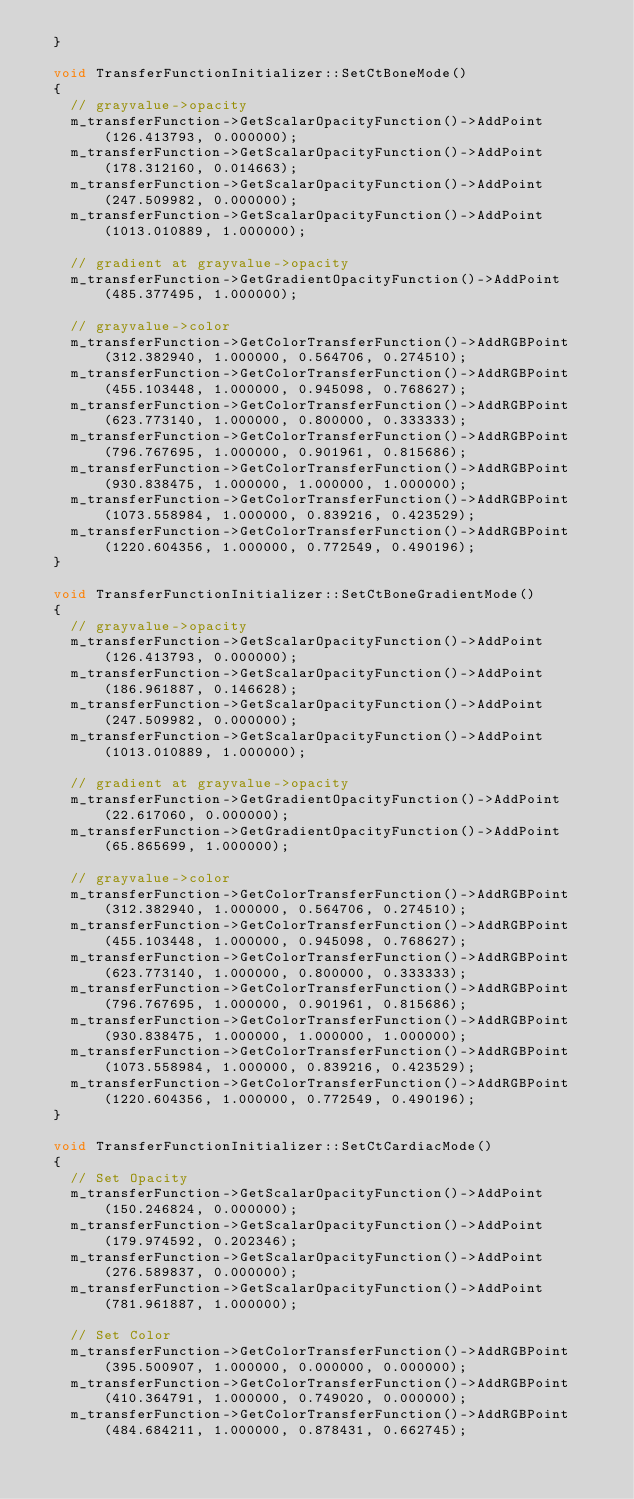Convert code to text. <code><loc_0><loc_0><loc_500><loc_500><_C++_>  }

  void TransferFunctionInitializer::SetCtBoneMode()
  {
    // grayvalue->opacity
    m_transferFunction->GetScalarOpacityFunction()->AddPoint(126.413793, 0.000000);
    m_transferFunction->GetScalarOpacityFunction()->AddPoint(178.312160, 0.014663);
    m_transferFunction->GetScalarOpacityFunction()->AddPoint(247.509982, 0.000000);
    m_transferFunction->GetScalarOpacityFunction()->AddPoint(1013.010889, 1.000000);

    // gradient at grayvalue->opacity
    m_transferFunction->GetGradientOpacityFunction()->AddPoint(485.377495, 1.000000);

    // grayvalue->color
    m_transferFunction->GetColorTransferFunction()->AddRGBPoint(312.382940, 1.000000, 0.564706, 0.274510);
    m_transferFunction->GetColorTransferFunction()->AddRGBPoint(455.103448, 1.000000, 0.945098, 0.768627);
    m_transferFunction->GetColorTransferFunction()->AddRGBPoint(623.773140, 1.000000, 0.800000, 0.333333);
    m_transferFunction->GetColorTransferFunction()->AddRGBPoint(796.767695, 1.000000, 0.901961, 0.815686);
    m_transferFunction->GetColorTransferFunction()->AddRGBPoint(930.838475, 1.000000, 1.000000, 1.000000);
    m_transferFunction->GetColorTransferFunction()->AddRGBPoint(1073.558984, 1.000000, 0.839216, 0.423529);
    m_transferFunction->GetColorTransferFunction()->AddRGBPoint(1220.604356, 1.000000, 0.772549, 0.490196);
  }

  void TransferFunctionInitializer::SetCtBoneGradientMode()
  {
    // grayvalue->opacity
    m_transferFunction->GetScalarOpacityFunction()->AddPoint(126.413793, 0.000000);
    m_transferFunction->GetScalarOpacityFunction()->AddPoint(186.961887, 0.146628);
    m_transferFunction->GetScalarOpacityFunction()->AddPoint(247.509982, 0.000000);
    m_transferFunction->GetScalarOpacityFunction()->AddPoint(1013.010889, 1.000000);

    // gradient at grayvalue->opacity
    m_transferFunction->GetGradientOpacityFunction()->AddPoint(22.617060, 0.000000);
    m_transferFunction->GetGradientOpacityFunction()->AddPoint(65.865699, 1.000000);

    // grayvalue->color
    m_transferFunction->GetColorTransferFunction()->AddRGBPoint(312.382940, 1.000000, 0.564706, 0.274510);
    m_transferFunction->GetColorTransferFunction()->AddRGBPoint(455.103448, 1.000000, 0.945098, 0.768627);
    m_transferFunction->GetColorTransferFunction()->AddRGBPoint(623.773140, 1.000000, 0.800000, 0.333333);
    m_transferFunction->GetColorTransferFunction()->AddRGBPoint(796.767695, 1.000000, 0.901961, 0.815686);
    m_transferFunction->GetColorTransferFunction()->AddRGBPoint(930.838475, 1.000000, 1.000000, 1.000000);
    m_transferFunction->GetColorTransferFunction()->AddRGBPoint(1073.558984, 1.000000, 0.839216, 0.423529);
    m_transferFunction->GetColorTransferFunction()->AddRGBPoint(1220.604356, 1.000000, 0.772549, 0.490196);
  }

  void TransferFunctionInitializer::SetCtCardiacMode()
  {
    // Set Opacity
    m_transferFunction->GetScalarOpacityFunction()->AddPoint(150.246824, 0.000000);
    m_transferFunction->GetScalarOpacityFunction()->AddPoint(179.974592, 0.202346);
    m_transferFunction->GetScalarOpacityFunction()->AddPoint(276.589837, 0.000000);
    m_transferFunction->GetScalarOpacityFunction()->AddPoint(781.961887, 1.000000);

    // Set Color
    m_transferFunction->GetColorTransferFunction()->AddRGBPoint(395.500907, 1.000000, 0.000000, 0.000000);
    m_transferFunction->GetColorTransferFunction()->AddRGBPoint(410.364791, 1.000000, 0.749020, 0.000000);
    m_transferFunction->GetColorTransferFunction()->AddRGBPoint(484.684211, 1.000000, 0.878431, 0.662745);</code> 